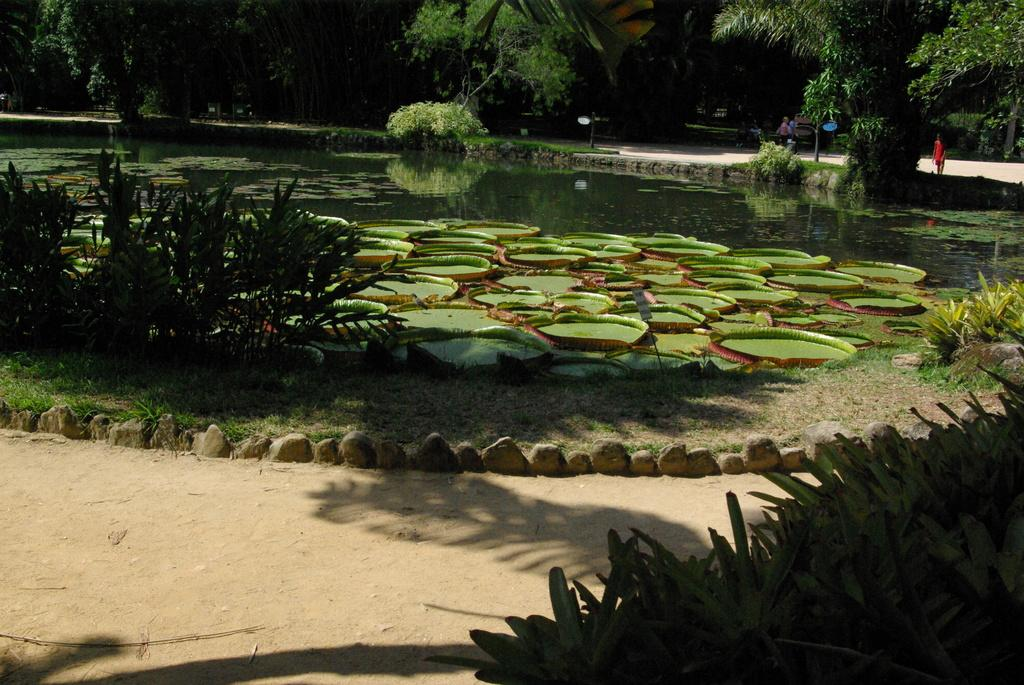What is located in the middle of the image? There is water in the middle of the image. What type of vegetation is at the bottom of the image? There is grass at the bottom of the image. What else can be seen in the image besides water and grass? There are plants visible in the image. What is visible in the background of the image? There are trees in the background of the image. What is the person in the image doing? The person is sitting in the image. How does the person in the image end the hot debate? There is no indication of a debate, hot or otherwise, in the image. The person is simply sitting. What type of rail can be seen in the image? There is no rail present in the image. 